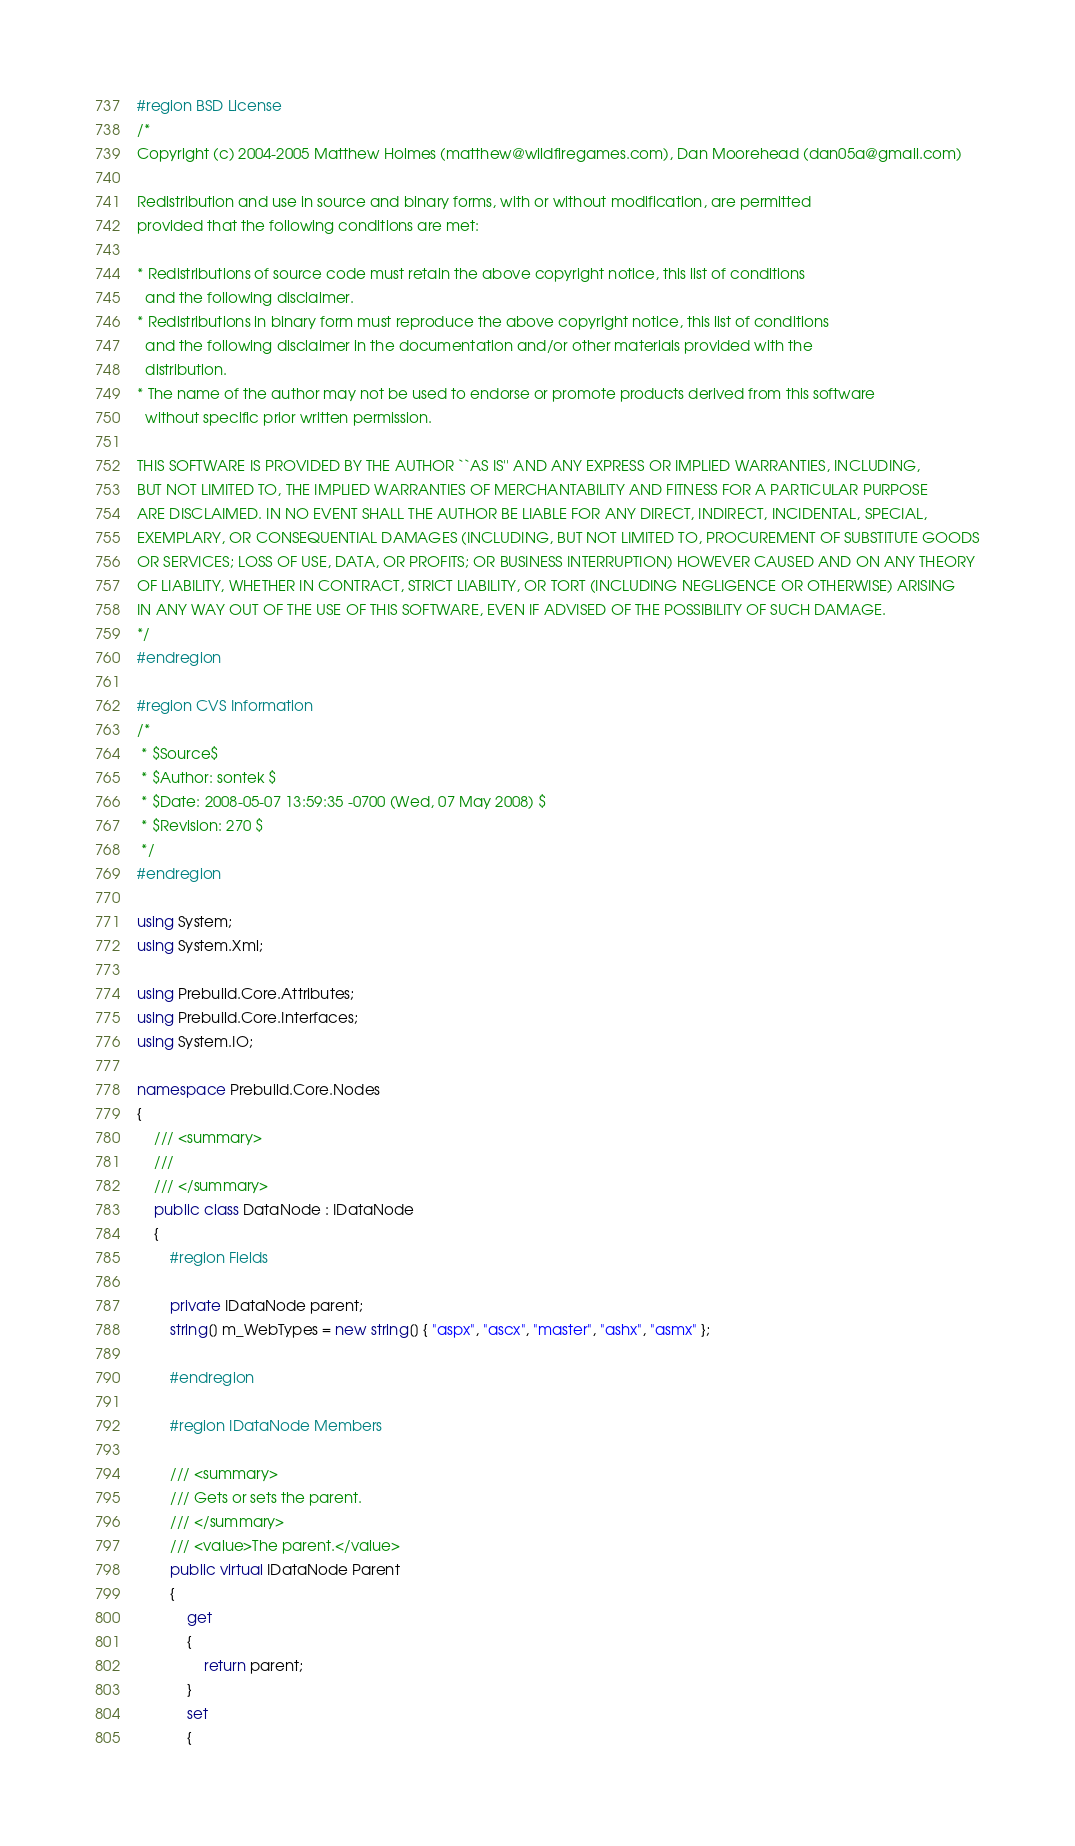<code> <loc_0><loc_0><loc_500><loc_500><_C#_>#region BSD License
/*
Copyright (c) 2004-2005 Matthew Holmes (matthew@wildfiregames.com), Dan Moorehead (dan05a@gmail.com)

Redistribution and use in source and binary forms, with or without modification, are permitted
provided that the following conditions are met:

* Redistributions of source code must retain the above copyright notice, this list of conditions 
  and the following disclaimer. 
* Redistributions in binary form must reproduce the above copyright notice, this list of conditions 
  and the following disclaimer in the documentation and/or other materials provided with the 
  distribution. 
* The name of the author may not be used to endorse or promote products derived from this software 
  without specific prior written permission. 

THIS SOFTWARE IS PROVIDED BY THE AUTHOR ``AS IS'' AND ANY EXPRESS OR IMPLIED WARRANTIES, INCLUDING, 
BUT NOT LIMITED TO, THE IMPLIED WARRANTIES OF MERCHANTABILITY AND FITNESS FOR A PARTICULAR PURPOSE 
ARE DISCLAIMED. IN NO EVENT SHALL THE AUTHOR BE LIABLE FOR ANY DIRECT, INDIRECT, INCIDENTAL, SPECIAL,
EXEMPLARY, OR CONSEQUENTIAL DAMAGES (INCLUDING, BUT NOT LIMITED TO, PROCUREMENT OF SUBSTITUTE GOODS
OR SERVICES; LOSS OF USE, DATA, OR PROFITS; OR BUSINESS INTERRUPTION) HOWEVER CAUSED AND ON ANY THEORY
OF LIABILITY, WHETHER IN CONTRACT, STRICT LIABILITY, OR TORT (INCLUDING NEGLIGENCE OR OTHERWISE) ARISING
IN ANY WAY OUT OF THE USE OF THIS SOFTWARE, EVEN IF ADVISED OF THE POSSIBILITY OF SUCH DAMAGE.
*/
#endregion

#region CVS Information
/*
 * $Source$
 * $Author: sontek $
 * $Date: 2008-05-07 13:59:35 -0700 (Wed, 07 May 2008) $
 * $Revision: 270 $
 */
#endregion

using System;
using System.Xml;

using Prebuild.Core.Attributes;
using Prebuild.Core.Interfaces;
using System.IO;

namespace Prebuild.Core.Nodes
{
	/// <summary>
	/// 
	/// </summary>
	public class DataNode : IDataNode
	{
		#region Fields

		private IDataNode parent;
		string[] m_WebTypes = new string[] { "aspx", "ascx", "master", "ashx", "asmx" };

		#endregion

		#region IDataNode Members

		/// <summary>
		/// Gets or sets the parent.
		/// </summary>
		/// <value>The parent.</value>
		public virtual IDataNode Parent
		{
			get
			{
				return parent;
			}
			set
			{</code> 